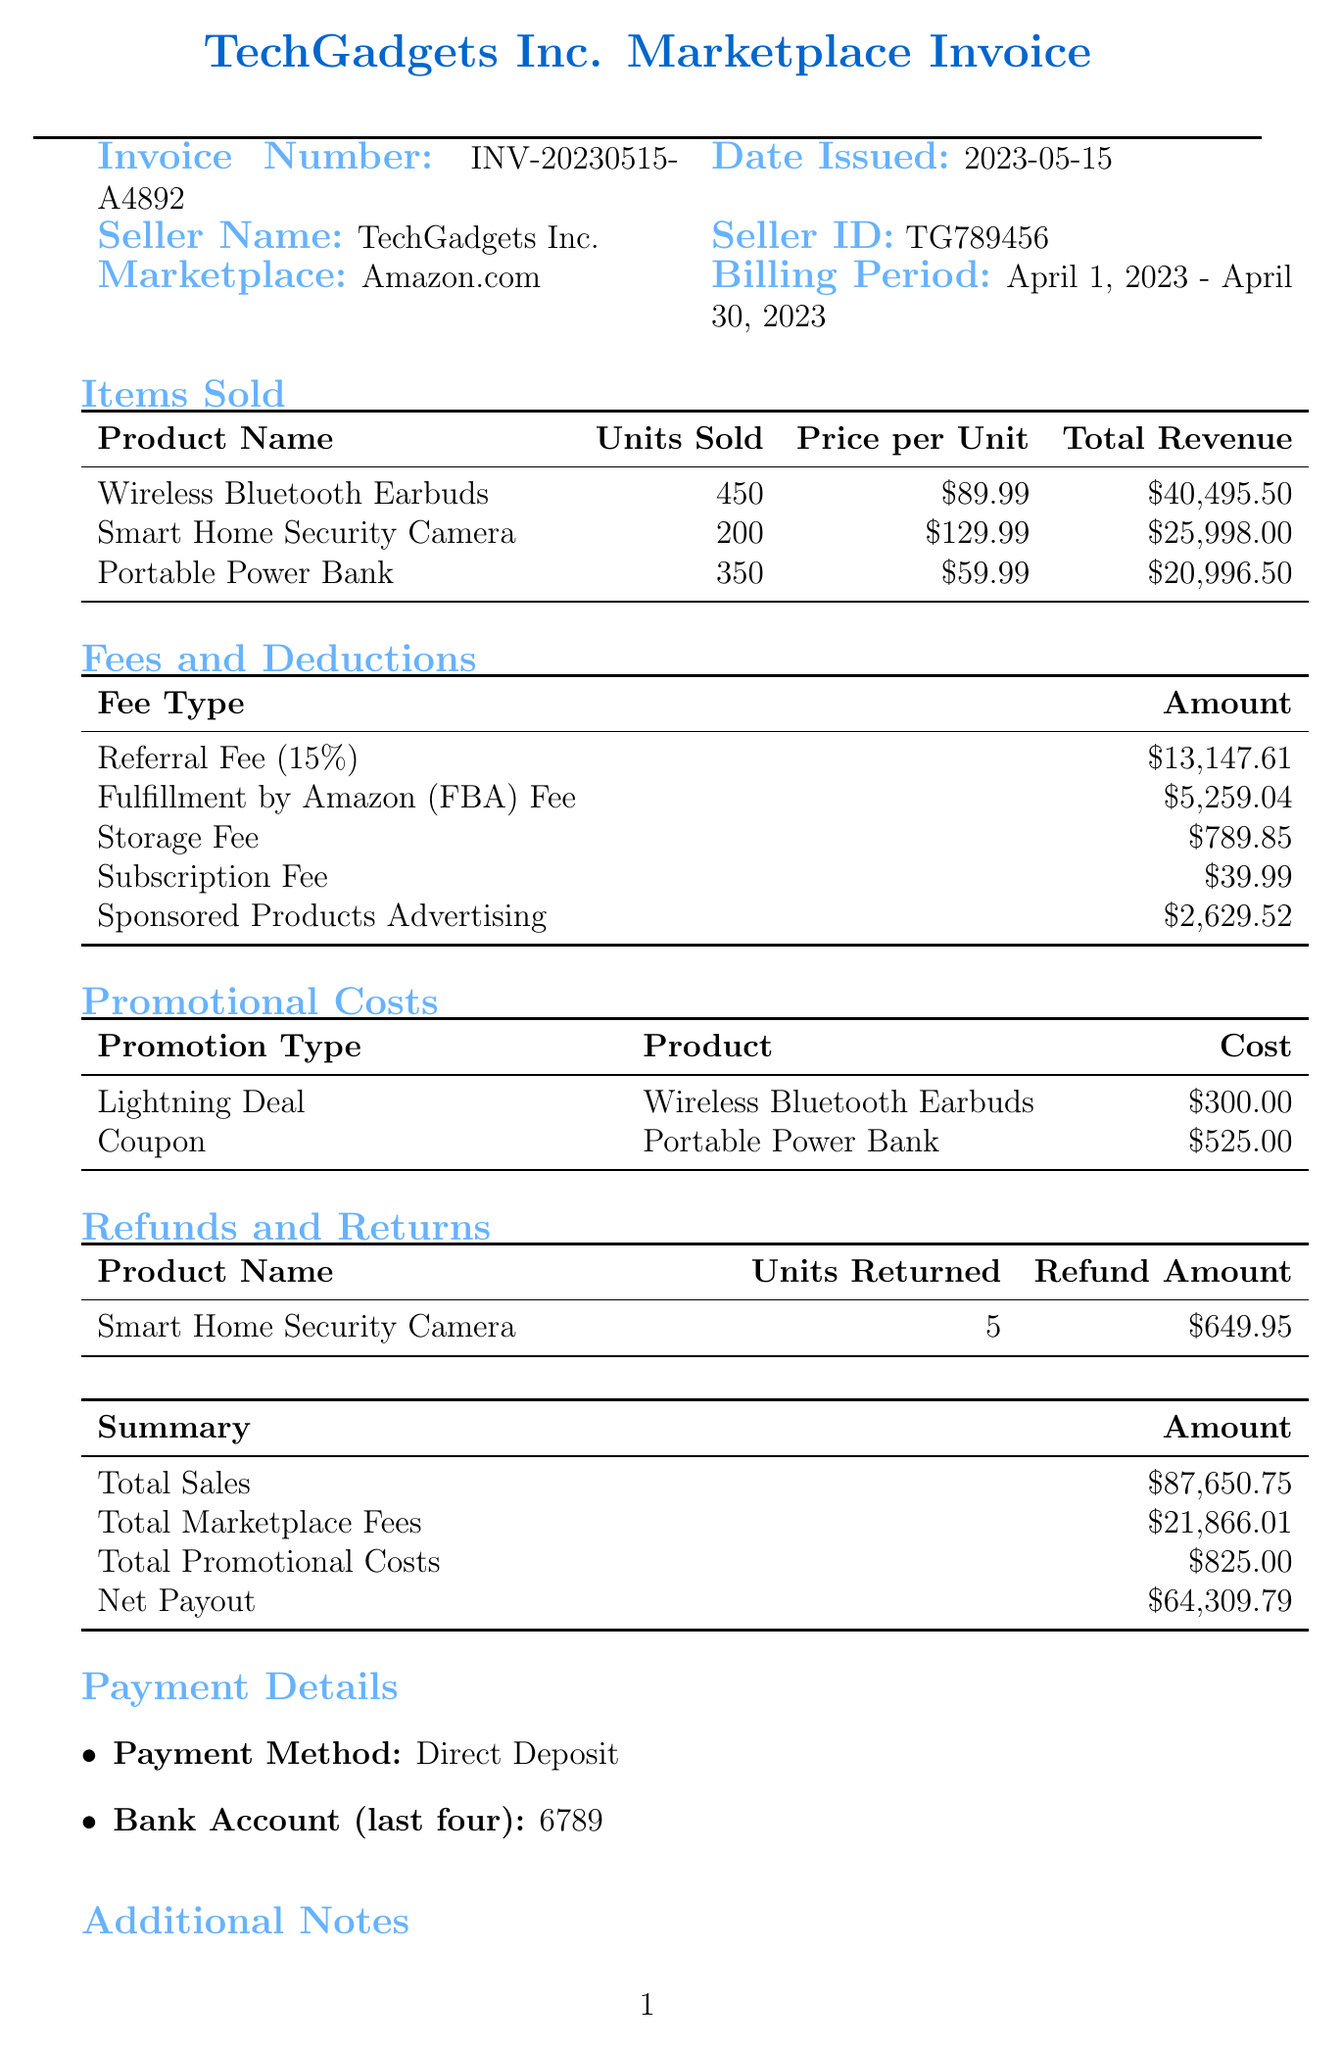what is the invoice number? The invoice number is a unique identifier for this document, specified in the header section.
Answer: INV-20230515-A4892 what is the total sales amount? The total sales amount is provided in the summary section of the invoice, representing all sales during the billing period.
Answer: $87,650.75 how many units of Smart Home Security Camera were sold? The number of units sold for Smart Home Security Camera is detailed in the items sold section of the invoice.
Answer: 200 what is the total amount of fees and deductions? The total amount of fees and deductions is calculated from the fees and deductions listed in the respective section.
Answer: $21,866.01 what promotion type was used for the Wireless Bluetooth Earbuds? The promotion type is mentioned in the promotional costs section specifically for this product.
Answer: Lightning Deal what was the refund amount for the returned Smart Home Security Camera? The refund amount is detailed under the refunds and returns section for the specific product.
Answer: $649.95 how much did TechGadgets Inc. spend on Sponsored Products Advertising? The amount spent is listed among the fees and deductions on the invoice.
Answer: $2,629.52 what payment method is listed for the net payout? The payment method is specified in the payment details section of the document.
Answer: Direct Deposit what are the last four digits of the bank account used for payment? The last four digits are provided in the payment details section for transparency regarding the payment.
Answer: 6789 